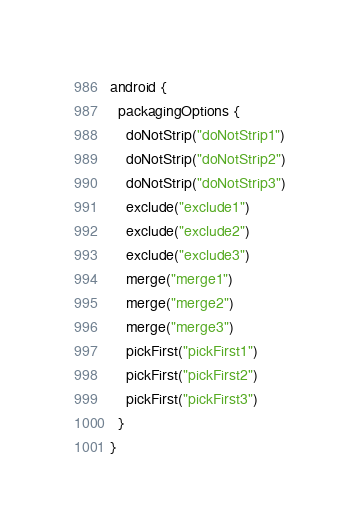<code> <loc_0><loc_0><loc_500><loc_500><_Kotlin_>android {
  packagingOptions {
    doNotStrip("doNotStrip1")
    doNotStrip("doNotStrip2")
    doNotStrip("doNotStrip3")
    exclude("exclude1")
    exclude("exclude2")
    exclude("exclude3")
    merge("merge1")
    merge("merge2")
    merge("merge3")
    pickFirst("pickFirst1")
    pickFirst("pickFirst2")
    pickFirst("pickFirst3")
  }
}
</code> 